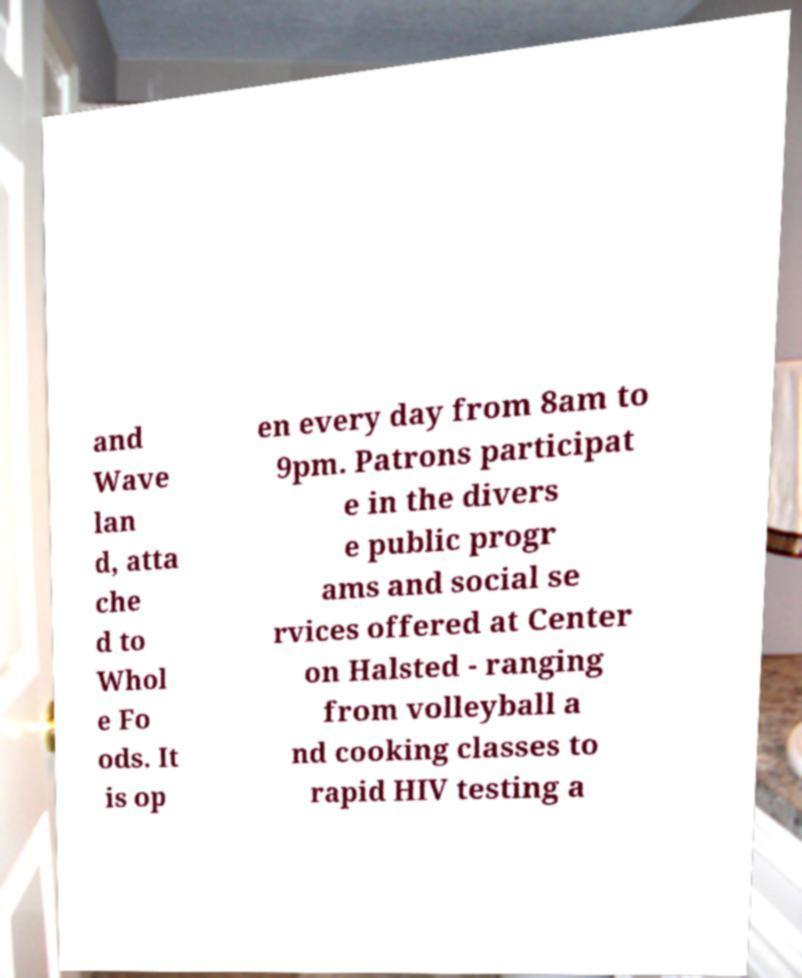For documentation purposes, I need the text within this image transcribed. Could you provide that? and Wave lan d, atta che d to Whol e Fo ods. It is op en every day from 8am to 9pm. Patrons participat e in the divers e public progr ams and social se rvices offered at Center on Halsted - ranging from volleyball a nd cooking classes to rapid HIV testing a 